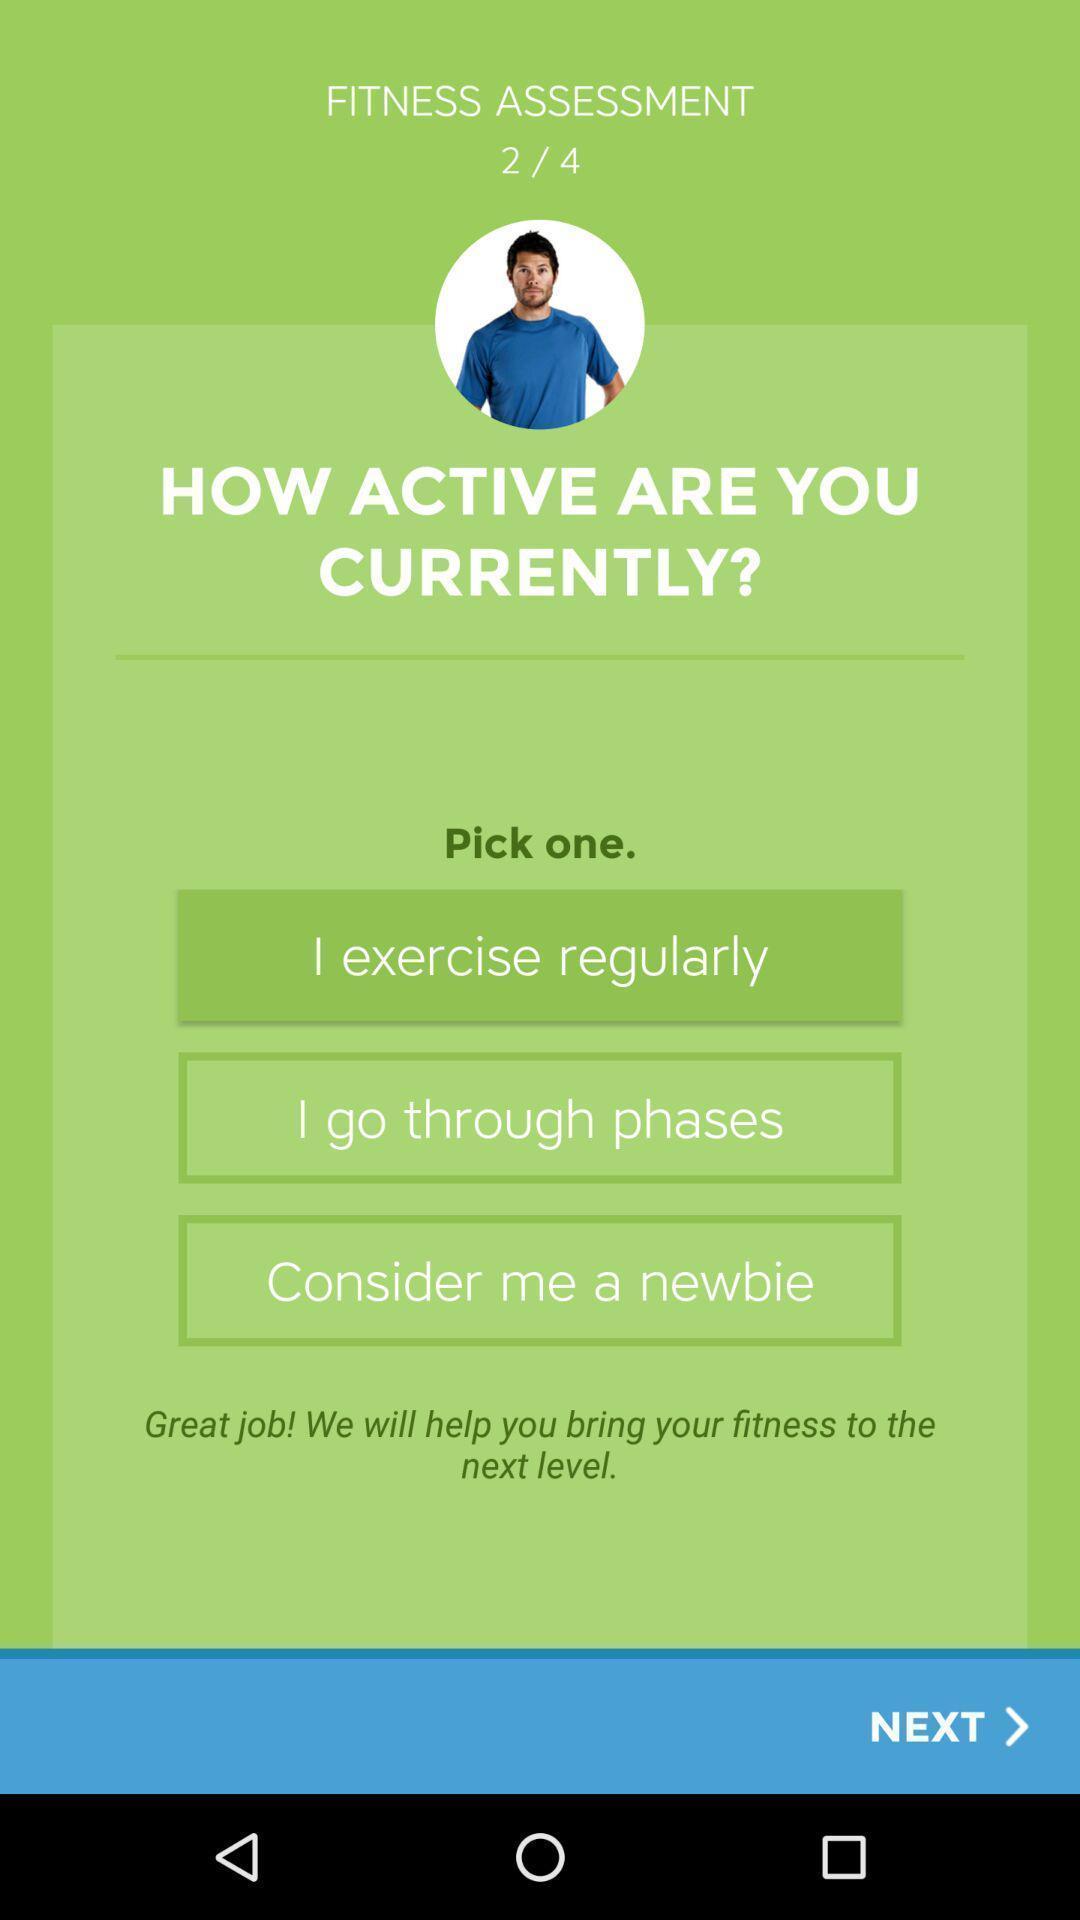Describe the visual elements of this screenshot. Welcome page with various options in fitness application. 